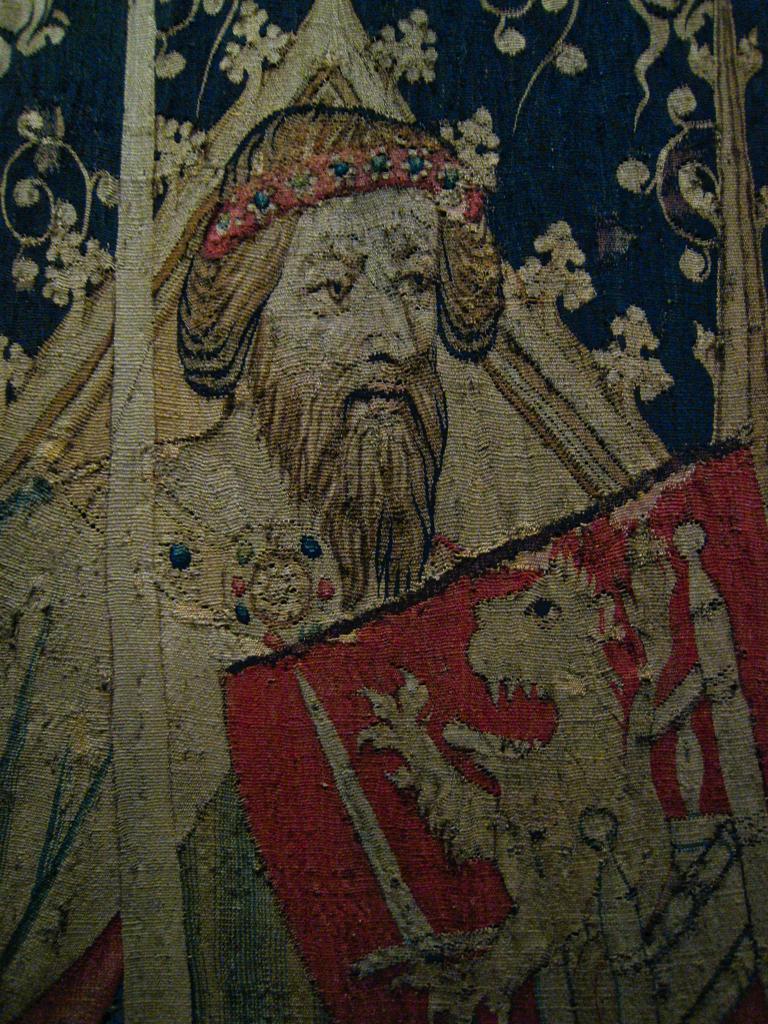Describe this image in one or two sentences. In this image, we can see pictures of a person and an animal are on the cloth. 